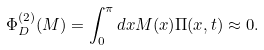Convert formula to latex. <formula><loc_0><loc_0><loc_500><loc_500>\Phi _ { D } ^ { ( 2 ) } ( M ) = \int _ { 0 } ^ { \pi } d x M ( x ) \Pi ( x , t ) \approx 0 .</formula> 